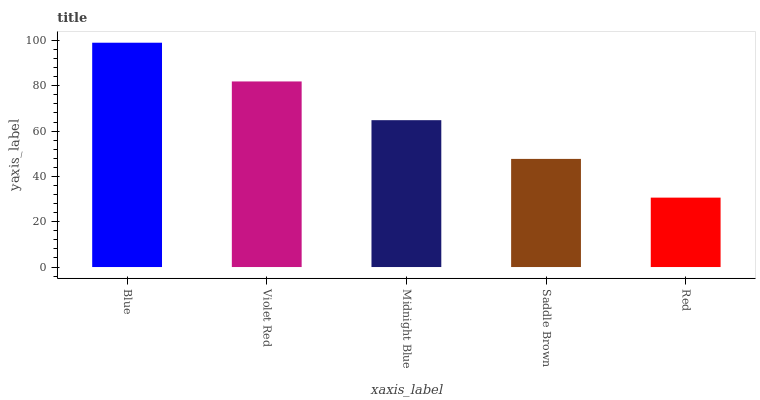Is Red the minimum?
Answer yes or no. Yes. Is Blue the maximum?
Answer yes or no. Yes. Is Violet Red the minimum?
Answer yes or no. No. Is Violet Red the maximum?
Answer yes or no. No. Is Blue greater than Violet Red?
Answer yes or no. Yes. Is Violet Red less than Blue?
Answer yes or no. Yes. Is Violet Red greater than Blue?
Answer yes or no. No. Is Blue less than Violet Red?
Answer yes or no. No. Is Midnight Blue the high median?
Answer yes or no. Yes. Is Midnight Blue the low median?
Answer yes or no. Yes. Is Violet Red the high median?
Answer yes or no. No. Is Red the low median?
Answer yes or no. No. 